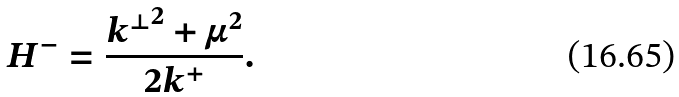Convert formula to latex. <formula><loc_0><loc_0><loc_500><loc_500>H ^ { - } = \frac { { k ^ { \perp } } ^ { 2 } + \mu ^ { 2 } } { 2 k ^ { + } } . \,</formula> 